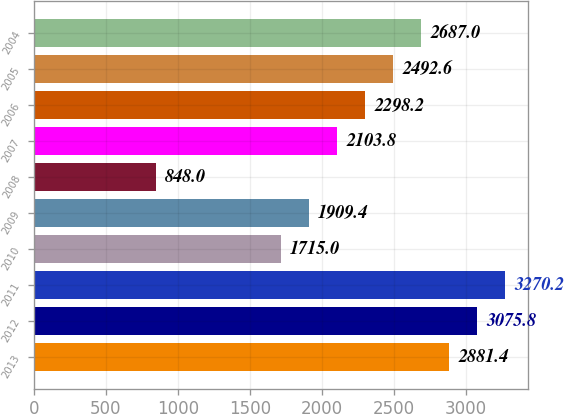Convert chart to OTSL. <chart><loc_0><loc_0><loc_500><loc_500><bar_chart><fcel>2013<fcel>2012<fcel>2011<fcel>2010<fcel>2009<fcel>2008<fcel>2007<fcel>2006<fcel>2005<fcel>2004<nl><fcel>2881.4<fcel>3075.8<fcel>3270.2<fcel>1715<fcel>1909.4<fcel>848<fcel>2103.8<fcel>2298.2<fcel>2492.6<fcel>2687<nl></chart> 